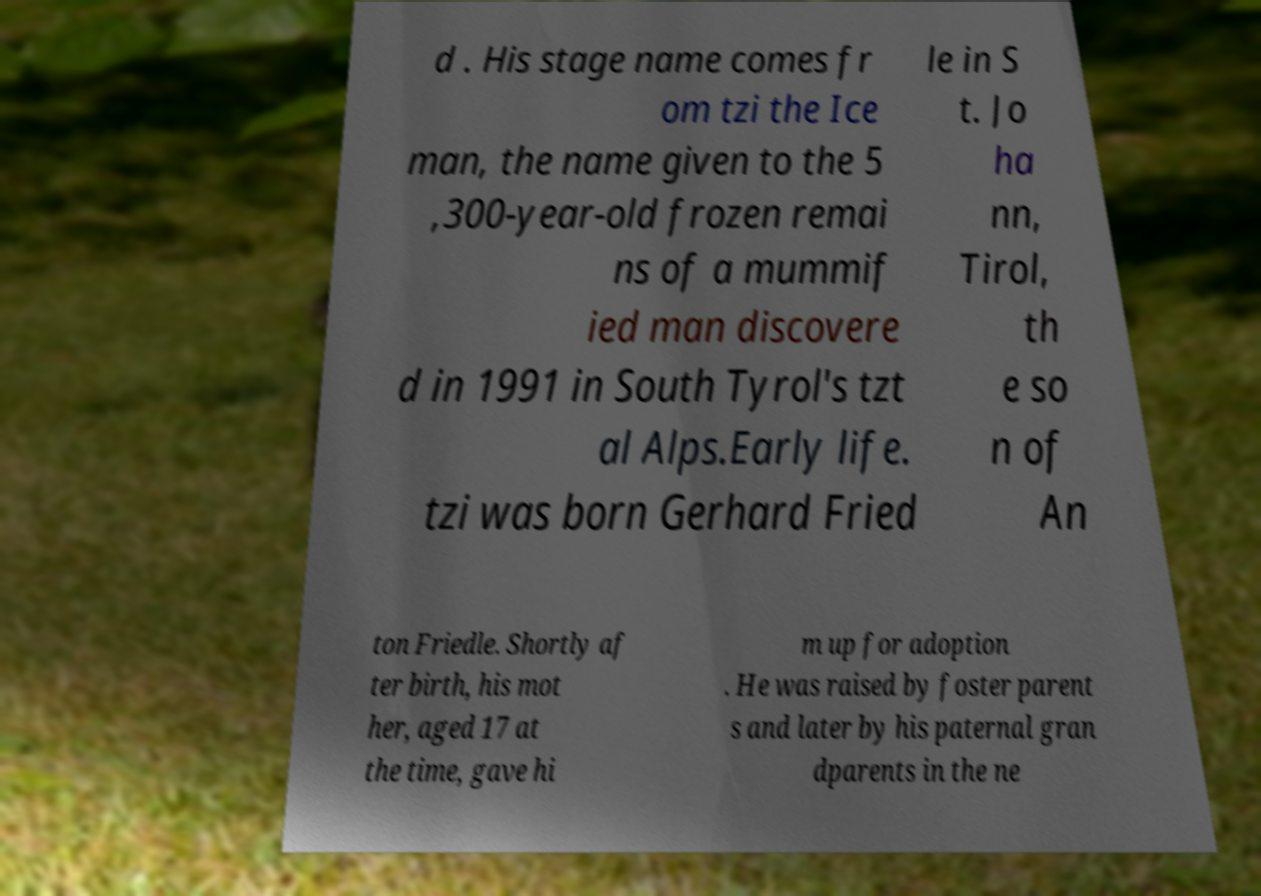What messages or text are displayed in this image? I need them in a readable, typed format. d . His stage name comes fr om tzi the Ice man, the name given to the 5 ,300-year-old frozen remai ns of a mummif ied man discovere d in 1991 in South Tyrol's tzt al Alps.Early life. tzi was born Gerhard Fried le in S t. Jo ha nn, Tirol, th e so n of An ton Friedle. Shortly af ter birth, his mot her, aged 17 at the time, gave hi m up for adoption . He was raised by foster parent s and later by his paternal gran dparents in the ne 